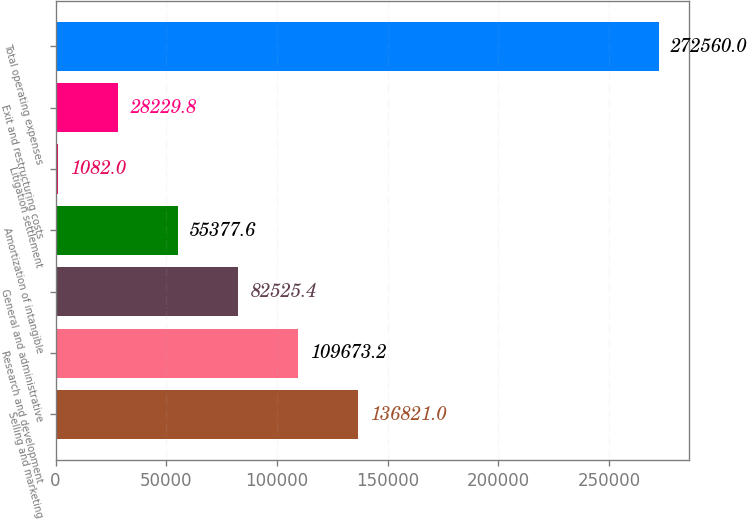<chart> <loc_0><loc_0><loc_500><loc_500><bar_chart><fcel>Selling and marketing<fcel>Research and development<fcel>General and administrative<fcel>Amortization of intangible<fcel>Litigation settlement<fcel>Exit and restructuring costs<fcel>Total operating expenses<nl><fcel>136821<fcel>109673<fcel>82525.4<fcel>55377.6<fcel>1082<fcel>28229.8<fcel>272560<nl></chart> 